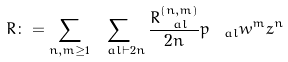<formula> <loc_0><loc_0><loc_500><loc_500>R \colon = \sum _ { n , m \geq 1 } \sum _ { \ a l \vdash 2 n } \frac { R _ { \ a l } ^ { ( n , m ) } } { 2 n } p _ { \ a l } w ^ { m } z ^ { n }</formula> 